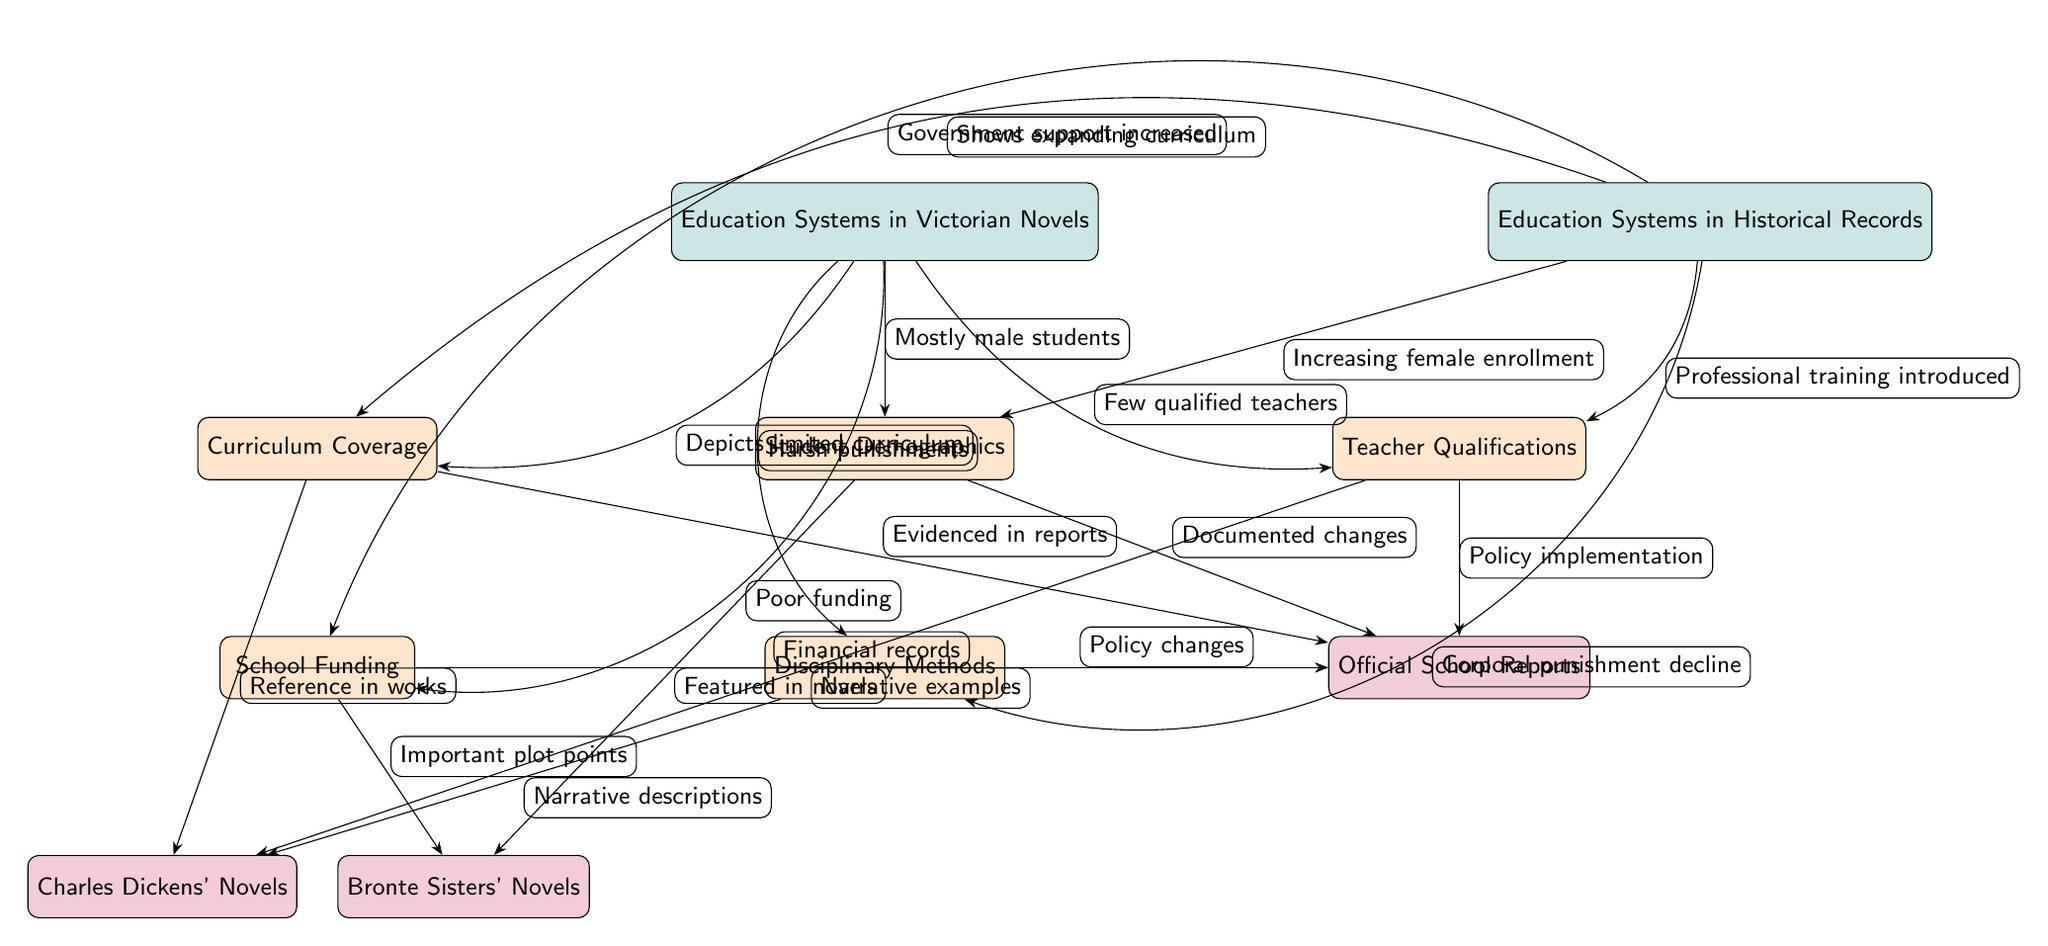What are the two main categories compared in the diagram? The diagram compares "Education Systems in Victorian Novels" and "Education Systems in Historical Records" as the two main categories. These are clearly labeled in the diagram and represent the two sides of the comparison.
Answer: Education Systems in Victorian Novels, Education Systems in Historical Records How many subcategories are listed under the education systems in Victorian novels? There are five subcategories depicted under "Education Systems in Victorian Novels." These include "Curriculum Coverage," "Student Demographics," "Teacher Qualifications," "School Funding," and "Disciplinary Methods." Each of these subcategories is connected to the main category in the diagram.
Answer: Five What does the relationship between "Curriculum Coverage" of Victorian novels and "Curriculum Coverage" of historical records indicate? The relationship indicates that the "Curriculum Coverage" in Victorian novels depicts a limited curriculum, while historical records show an expanding curriculum. This contrast points to a significant difference in the representation of educational content.
Answer: Depicts limited curriculum, Shows expanding curriculum Which node indicates that "Few qualified teachers" is a depiction of Victorian novels? The node that indicates "Few qualified teachers" is directly connected from the main node "Education Systems in Victorian Novels," which shows how few qualified teachers were reflected in that time's literature.
Answer: Teacher Qualifications What sources are connected to "Disciplinary Methods" in the diagram? "Disciplinary Methods" is connected to two sources: "Charles Dickens' Novels," which provide narrative descriptions of discipline, and "Official School Reports," which document policy changes regarding discipline. This implies that both literature and official documentation provide insights into disciplinary methods of the era.
Answer: Charles Dickens' Novels, Official School Reports What does the edge labeled "Harsh punishments" connect to in the Victorian novels section? The edge labeled "Harsh punishments" connects from the main node "Education Systems in Victorian Novels" to the subcategory "Disciplinary Methods." This illustrates how harsh punitive measures were a representation of educational discipline in the novels from that period.
Answer: Disciplinary Methods How does the "Demographics" node differ between Victorian novels and historical records? The "Demographics" node in Victorian novels indicates "Mostly male students," whereas in historical records, it indicates "Increasing female enrollment." This highlights a social change in student demographics across the two contexts.
Answer: Mostly male students, Increasing female enrollment What type of training is shown to have been introduced according to historical records in relation to "Teacher Qualifications"? The historical records show "Professional training introduced" related to "Teacher Qualifications." This indicates a shift towards more formalized training for teachers, contrasting with the previous depictions in Victorian novels.
Answer: Professional training introduced 